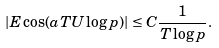<formula> <loc_0><loc_0><loc_500><loc_500>\left | E \cos ( a T U \log p ) \right | \leq C \frac { 1 } { T \log p } .</formula> 